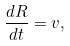Convert formula to latex. <formula><loc_0><loc_0><loc_500><loc_500>\frac { d R } { d t } = v ,</formula> 